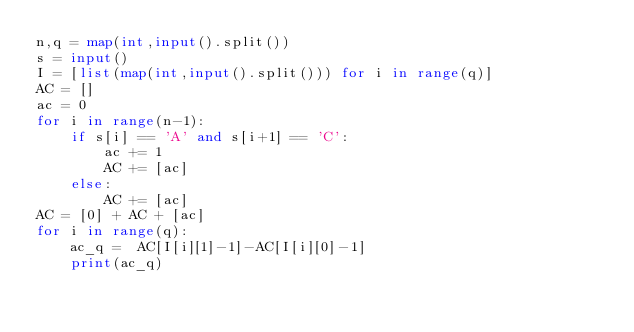<code> <loc_0><loc_0><loc_500><loc_500><_Python_>n,q = map(int,input().split())
s = input()
I = [list(map(int,input().split())) for i in range(q)]
AC = []
ac = 0
for i in range(n-1):
    if s[i] == 'A' and s[i+1] == 'C':
        ac += 1
        AC += [ac]
    else:
        AC += [ac]
AC = [0] + AC + [ac]
for i in range(q):
    ac_q =  AC[I[i][1]-1]-AC[I[i][0]-1]
    print(ac_q)</code> 